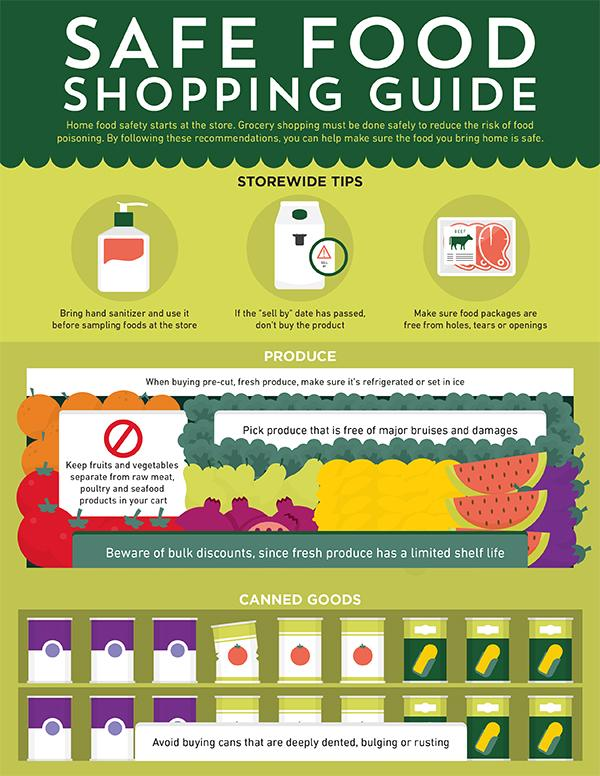List a handful of essential elements in this visual. The packaging of the meat product clearly states that it is beef. Fresh produce would be found under the category of fruits and vegetables, cereals, and canned goods. Packaged food items, canned goods, cereals, and fresh produce are typically categorized as non-perishable food items. 